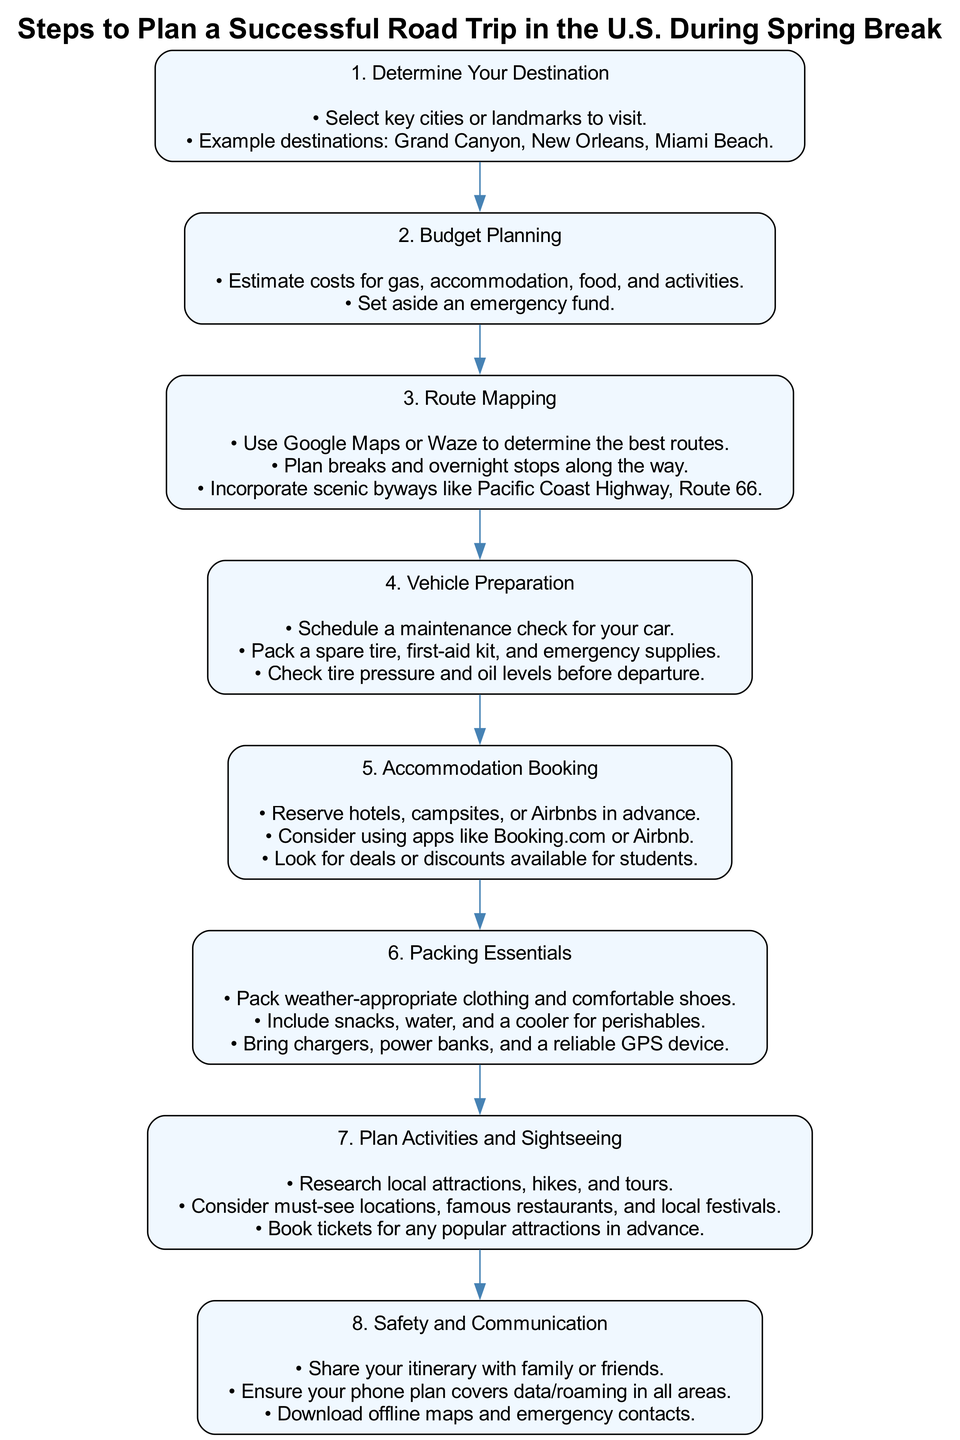What is Step 3 in the diagram? Step 3 in the diagram is titled "Route Mapping." This can be identified by locating the node labeled with the number three, indicating its order in the sequence.
Answer: Route Mapping How many steps are there in total in the flow chart? By counting each labeled step in the flow chart, we can see there are eight distinct steps listed.
Answer: 8 What are two example destinations mentioned in Step 1? The details under Step 1, "Determine Your Destination," include two examples: Grand Canyon and Miami Beach. These are specified in the details section of that step.
Answer: Grand Canyon, Miami Beach Which step comes before "Plan Activities and Sightseeing"? By following the flow of the diagram, we see that Step 7, "Plan Activities and Sightseeing," follows directly after Step 6, "Packing Essentials." The relationship between the steps indicates that Step 6 is the predecessor.
Answer: Packing Essentials What supplies should be packed as indicated in Step 4? In Step 4, "Vehicle Preparation," it specifies that a spare tire, first-aid kit, and emergency supplies should be packed. These are directly mentioned in the details for that step.
Answer: Spare tire, first-aid kit, emergency supplies Which node mentions using apps like Booking.com or Airbnb? Referring to the flow chart, it is Step 5, "Accommodation Booking," that lists using apps like Booking.com or Airbnb as a way to reserve places to stay. This is highlighted in the details of that step.
Answer: Accommodation Booking Which step emphasizes safety and communication? The focus on safety and communication is clearly attributed to Step 8, which is labeled as "Safety and Communication" in the diagram, making it directly identifiable.
Answer: Safety and Communication What is the main focus of Step 2? Step 2, titled "Budget Planning," primarily concentrates on estimating costs for various travel-related expenses such as gas, accommodation, and food. This is stated clearly in the details of that step.
Answer: Budget Planning 